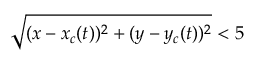Convert formula to latex. <formula><loc_0><loc_0><loc_500><loc_500>\sqrt { ( x - x _ { c } ( t ) ) ^ { 2 } + ( y - y _ { c } ( t ) ) ^ { 2 } } < 5</formula> 